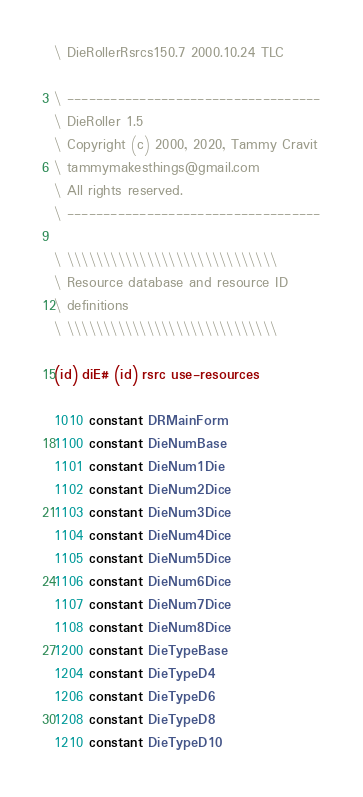<code> <loc_0><loc_0><loc_500><loc_500><_Forth_>\ DieRollerRsrcs150.7 2000.10.24 TLC

\ -----------------------------------
\ DieRoller 1.5
\ Copyright (c) 2000, 2020, Tammy Cravit
\ tammymakesthings@gmail.com
\ All rights reserved.
\ -----------------------------------

\ \\\\\\\\\\\\\\\\\\\\\\\\\\\\\
\ Resource database and resource ID
\ definitions
\ \\\\\\\\\\\\\\\\\\\\\\\\\\\\\

(id) diE# (id) rsrc use-resources

1010 constant DRMainForm
1100 constant DieNumBase
1101 constant DieNum1Die
1102 constant DieNum2Dice
1103 constant DieNum3Dice
1104 constant DieNum4Dice
1105 constant DieNum5Dice
1106 constant DieNum6Dice
1107 constant DieNum7Dice
1108 constant DieNum8Dice
1200 constant DieTypeBase
1204 constant DieTypeD4
1206 constant DieTypeD6
1208 constant DieTypeD8
1210 constant DieTypeD10</code> 